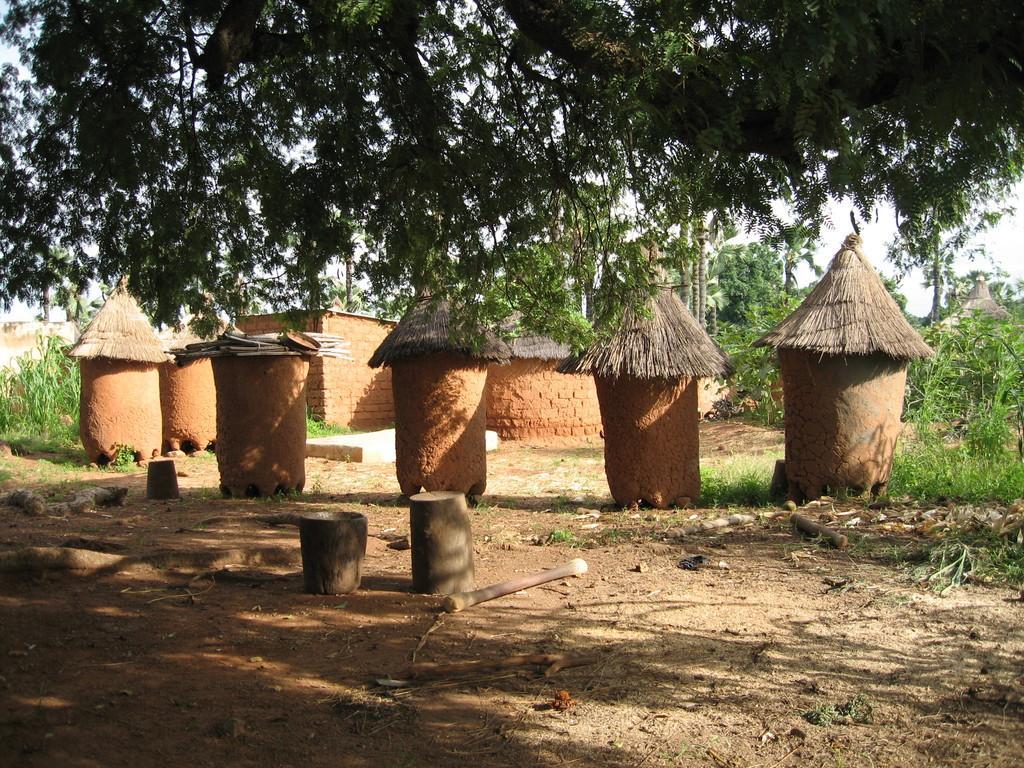Can you describe this image briefly? In this image I can see there are in the middle, at the top there are trees. 